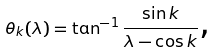Convert formula to latex. <formula><loc_0><loc_0><loc_500><loc_500>\theta _ { k } ( \lambda ) = \tan ^ { - 1 } \frac { \sin k } { \lambda - \cos k } \text {,}</formula> 